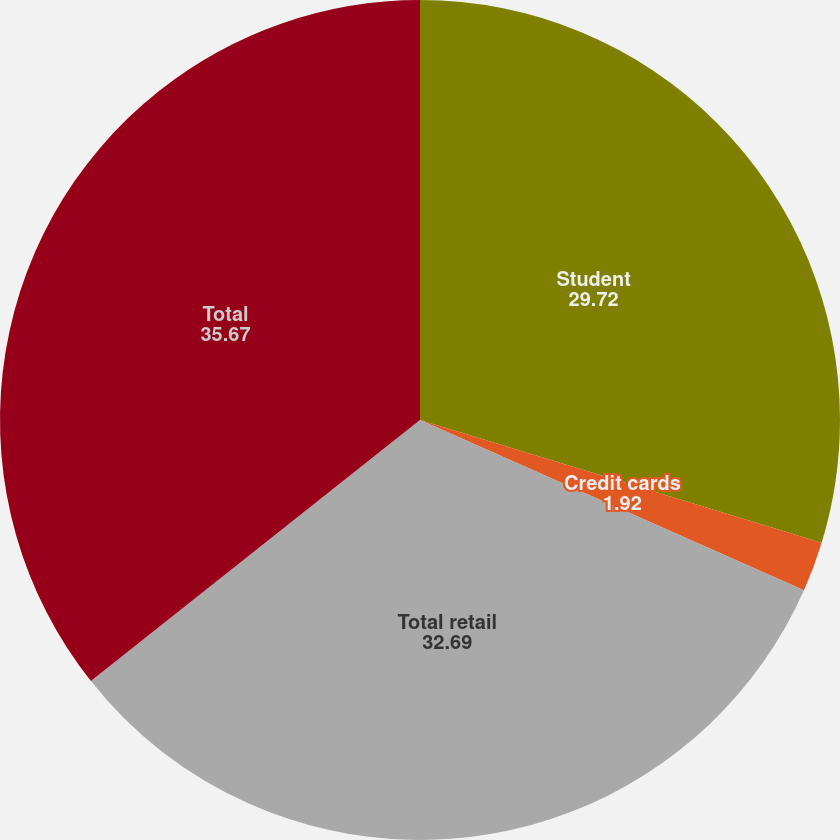Convert chart to OTSL. <chart><loc_0><loc_0><loc_500><loc_500><pie_chart><fcel>Student<fcel>Credit cards<fcel>Total retail<fcel>Total<nl><fcel>29.72%<fcel>1.92%<fcel>32.69%<fcel>35.67%<nl></chart> 